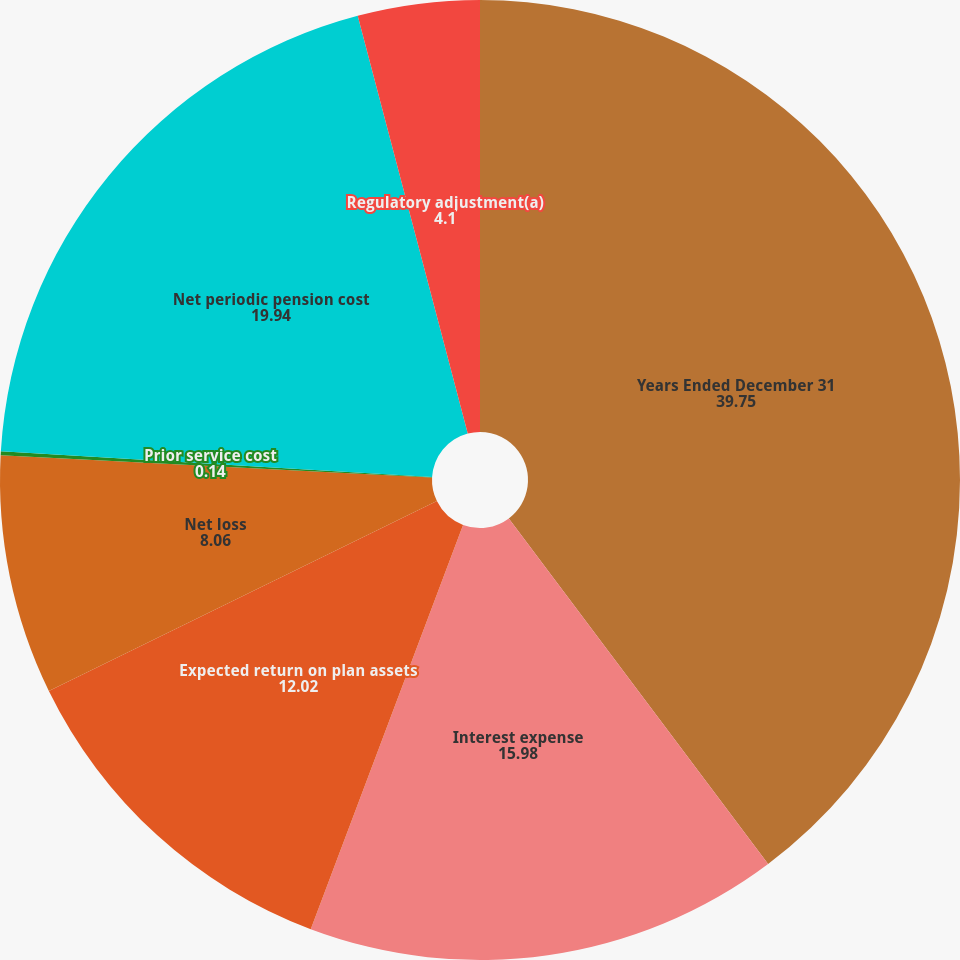Convert chart to OTSL. <chart><loc_0><loc_0><loc_500><loc_500><pie_chart><fcel>Years Ended December 31<fcel>Interest expense<fcel>Expected return on plan assets<fcel>Net loss<fcel>Prior service cost<fcel>Net periodic pension cost<fcel>Regulatory adjustment(a)<nl><fcel>39.75%<fcel>15.98%<fcel>12.02%<fcel>8.06%<fcel>0.14%<fcel>19.94%<fcel>4.1%<nl></chart> 